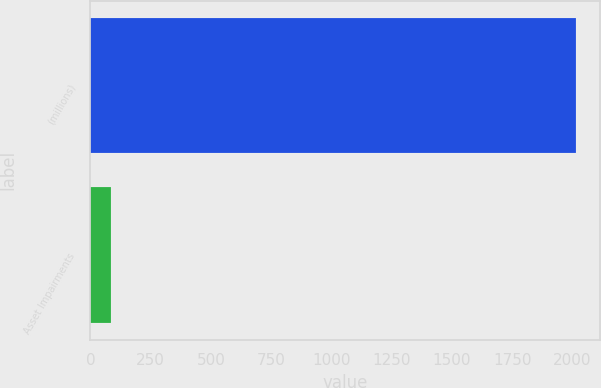Convert chart. <chart><loc_0><loc_0><loc_500><loc_500><bar_chart><fcel>(millions)<fcel>Asset Impairments<nl><fcel>2013<fcel>86<nl></chart> 